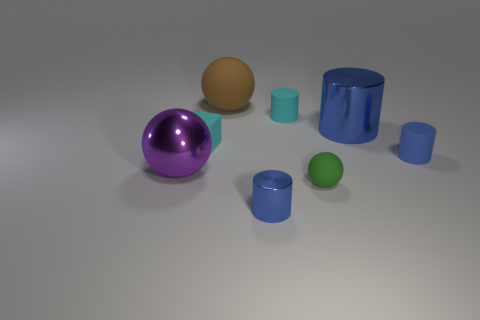There is a blue metal thing that is the same size as the brown ball; what shape is it?
Give a very brief answer. Cylinder. Are there fewer small cyan rubber things than big purple spheres?
Offer a very short reply. No. How many blue rubber objects are the same size as the cyan matte cylinder?
Your answer should be compact. 1. What material is the block?
Ensure brevity in your answer.  Rubber. What is the size of the shiny cylinder that is on the right side of the tiny green object?
Keep it short and to the point. Large. How many purple things are the same shape as the large brown object?
Offer a very short reply. 1. There is a big object that is the same material as the block; what is its shape?
Provide a short and direct response. Sphere. How many cyan things are either big matte objects or small cylinders?
Make the answer very short. 1. Are there any large matte things in front of the tiny matte ball?
Give a very brief answer. No. There is a small rubber thing that is in front of the big metal sphere; is it the same shape as the tiny rubber thing behind the tiny cyan rubber block?
Your answer should be compact. No. 